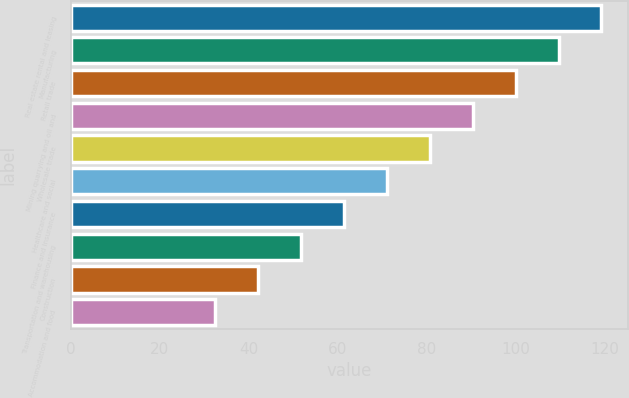Convert chart. <chart><loc_0><loc_0><loc_500><loc_500><bar_chart><fcel>Real estate rental and leasing<fcel>Manufacturing<fcel>Retail trade<fcel>Mining quarrying and oil and<fcel>Wholesale trade<fcel>Healthcare and social<fcel>Finance and insurance<fcel>Transportation and warehousing<fcel>Construction<fcel>Accommodation and food<nl><fcel>119.28<fcel>109.64<fcel>100<fcel>90.36<fcel>80.72<fcel>71.08<fcel>61.44<fcel>51.8<fcel>42.16<fcel>32.52<nl></chart> 